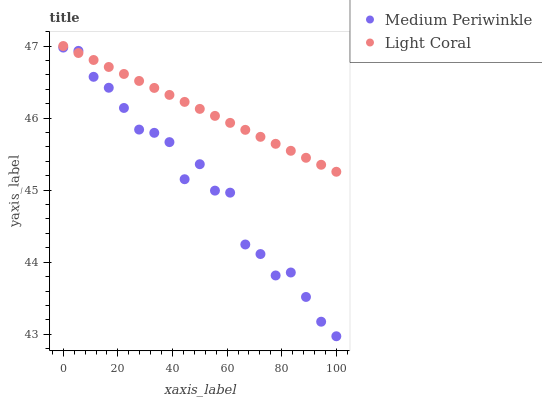Does Medium Periwinkle have the minimum area under the curve?
Answer yes or no. Yes. Does Light Coral have the maximum area under the curve?
Answer yes or no. Yes. Does Medium Periwinkle have the maximum area under the curve?
Answer yes or no. No. Is Light Coral the smoothest?
Answer yes or no. Yes. Is Medium Periwinkle the roughest?
Answer yes or no. Yes. Is Medium Periwinkle the smoothest?
Answer yes or no. No. Does Medium Periwinkle have the lowest value?
Answer yes or no. Yes. Does Light Coral have the highest value?
Answer yes or no. Yes. Does Medium Periwinkle have the highest value?
Answer yes or no. No. Does Light Coral intersect Medium Periwinkle?
Answer yes or no. Yes. Is Light Coral less than Medium Periwinkle?
Answer yes or no. No. Is Light Coral greater than Medium Periwinkle?
Answer yes or no. No. 